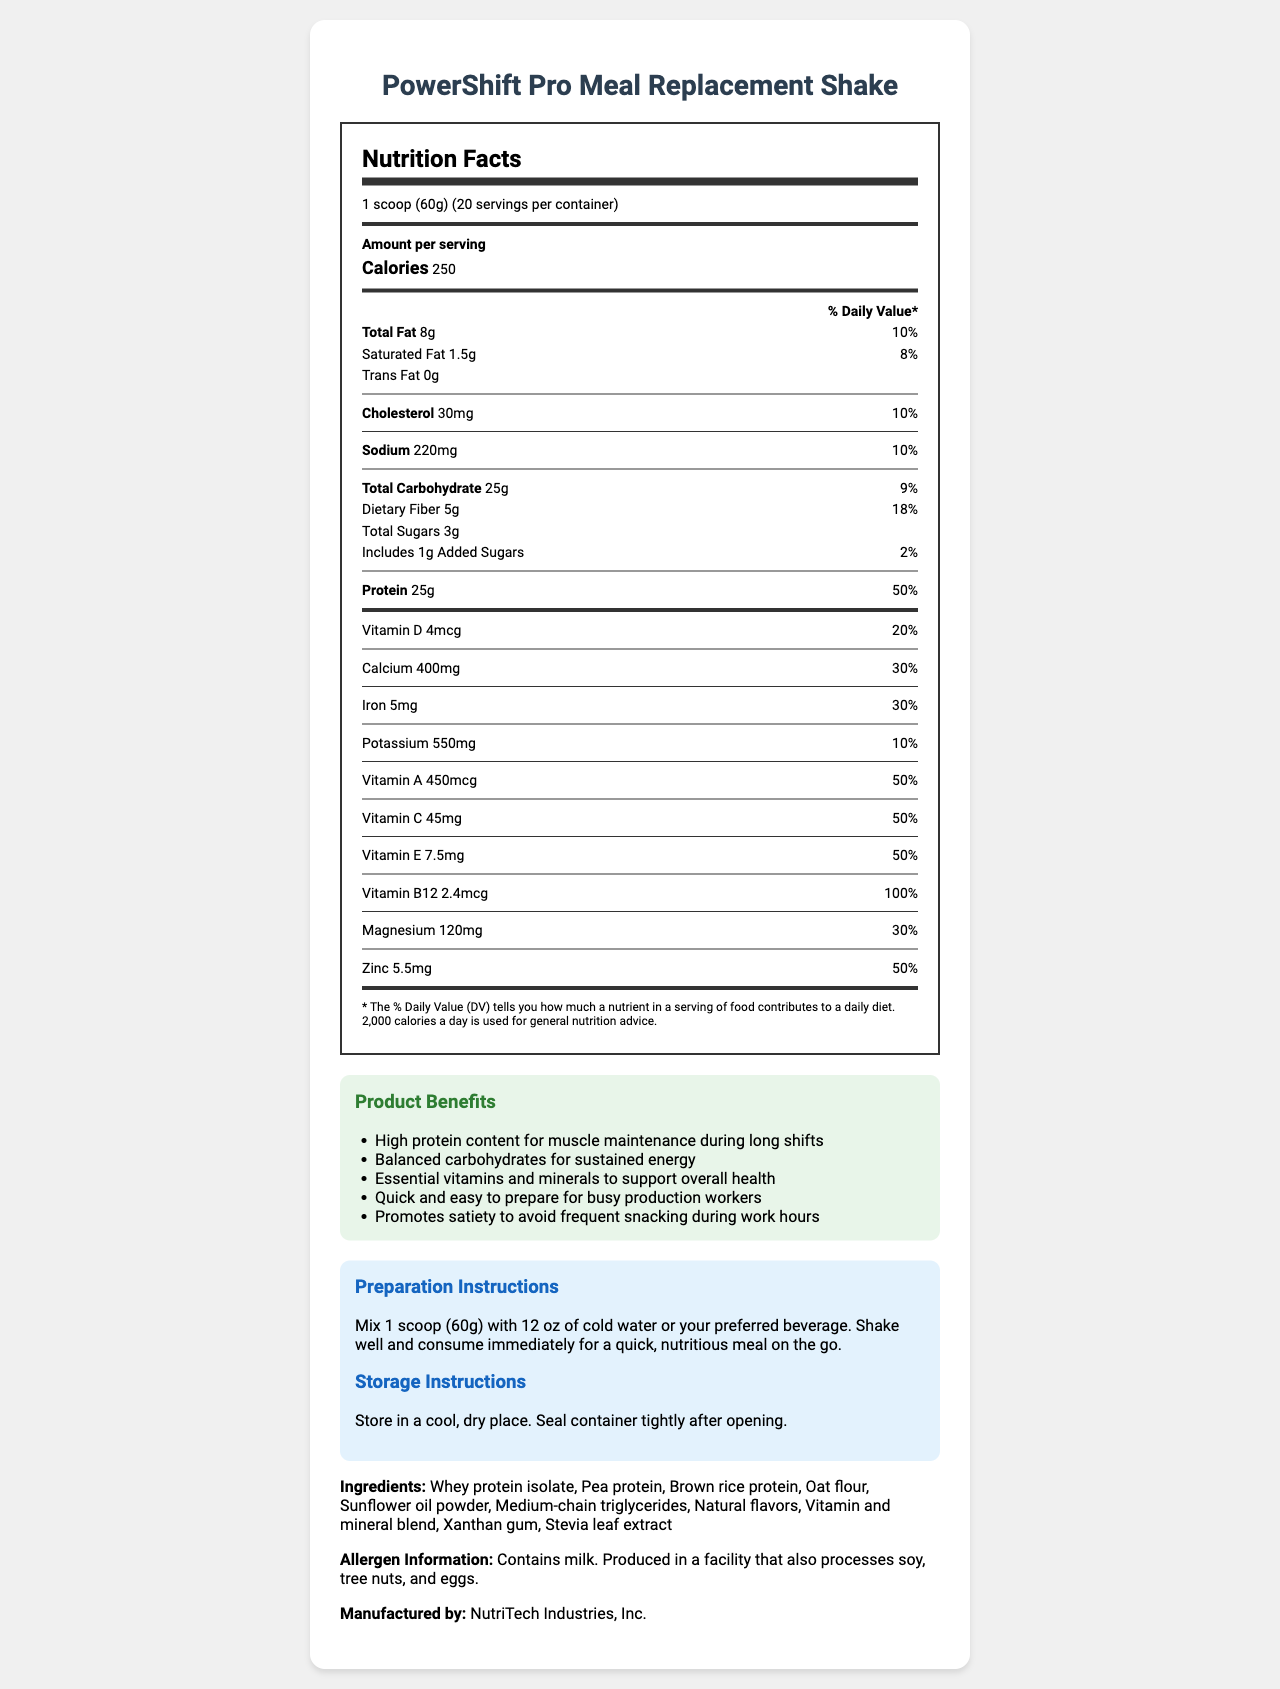what is the serving size? The serving size is indicated as "1 scoop (60g)" on the nutrition label.
Answer: 1 scoop (60g) how many servings are in the container? The number of servings per container is specified as 20.
Answer: 20 how many calories are in one serving? The nutrition label shows that each serving contains 250 calories.
Answer: 250 what is the total fat content per serving? The total fat content per serving is listed as 8g on the nutrition label.
Answer: 8g what percentage of the daily value is the protein content? The daily value percentage for protein is indicated as 50% for each serving.
Answer: 50% what type of vitamins are included in the product? A. Vitamin A and D B. Vitamin C and E C. Vitamin B12 and Zinc D. All of the above The nutrition label lists Vitamin A, D, C, E, and B12, along with Zinc as part of the nutrients in the product.
Answer: D. All of the above what is the amount of iron in the product? A. 4mg B. 5mg C. 6mg D. 7mg The nutrition label specifies that there are 5mg of iron per serving.
Answer: B. 5mg is the product suitable for people with soy allergies? Although the allergen information mentions that the product is produced in a facility that processes soy, it does not specify whether the product itself contains soy.
Answer: Not enough information what are the instructions for preparing the shake? The preparation instructions are clearly outlined under the preparation instructions section in the document.
Answer: Mix 1 scoop (60g) with 12 oz of cold water or your preferred beverage. Shake well and consume immediately for a quick, nutritious meal on the go. how should the product be stored? The storage instructions specify storing in a cool, dry place and to seal the container tightly after opening.
Answer: Store in a cool, dry place. Seal container tightly after opening. what percentage of daily value is the dietary fiber content? The daily value percentage for dietary fiber is indicated as 18%.
Answer: 18% does the product contain added sugars? The nutrition label states that there are 1g of added sugars per serving, which accounts for 2% of the daily value.
Answer: Yes summarize the key benefits and features of the product described in the document. The document emphasizes that the product is high in protein, contains balanced carbohydrates and essential vitamins and minerals, and is beneficial for muscle maintenance and overall health. It is quick to prepare and designed to be a convenient option for production workers.
Answer: The PowerShift Pro Meal Replacement Shake provides a high-protein, nutrient-dense option designed for busy production workers. It offers balanced carbohydrates, essential vitamins and minerals, and is quick and easy to prepare. The shake promotes satiety and supports muscle maintenance. what is the manufacturer's name? The document states that the product is manufactured by NutriTech Industries, Inc.
Answer: NutriTech Industries, Inc. 